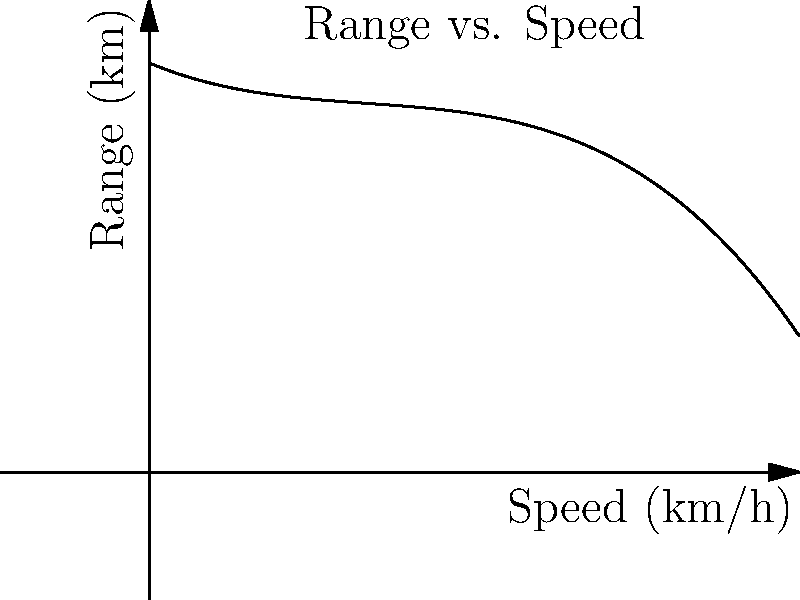As a retiree considering an electric vehicle purchase, you come across a graph showing the relationship between speed and range for a popular EV model. The range (R) in kilometers can be estimated using the polynomial function $R(s) = -0.0005s^3 + 0.05s^2 - 2s + 300$, where $s$ is the speed in km/h. At what speed should you drive to maximize the vehicle's range, and what is the maximum range? To find the maximum range, we need to determine the speed at which the derivative of the range function equals zero:

1) First, calculate the derivative of $R(s)$:
   $R'(s) = -0.0015s^2 + 0.1s - 2$

2) Set $R'(s) = 0$ and solve for $s$:
   $-0.0015s^2 + 0.1s - 2 = 0$

3) This is a quadratic equation. We can solve it using the quadratic formula:
   $s = \frac{-b \pm \sqrt{b^2 - 4ac}}{2a}$

   Where $a = -0.0015$, $b = 0.1$, and $c = -2$

4) Plugging in these values:
   $s = \frac{-0.1 \pm \sqrt{0.1^2 - 4(-0.0015)(-2)}}{2(-0.0015)}$

5) Solving this equation gives us two solutions:
   $s \approx 20.0$ km/h or $s \approx 46.7$ km/h

6) The second solution (46.7 km/h) gives the maximum, as it's the peak of the curve.

7) To find the maximum range, plug this speed back into the original function:
   $R(46.7) = -0.0005(46.7)^3 + 0.05(46.7)^2 - 2(46.7) + 300 \approx 301.8$ km

Therefore, the maximum range is achieved at a speed of about 46.7 km/h, and the maximum range is approximately 301.8 km.
Answer: Speed: 46.7 km/h; Maximum range: 301.8 km 